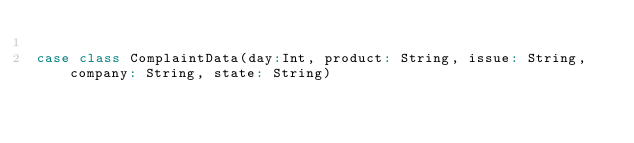Convert code to text. <code><loc_0><loc_0><loc_500><loc_500><_Scala_>
case class ComplaintData(day:Int, product: String, issue: String, company: String, state: String)</code> 